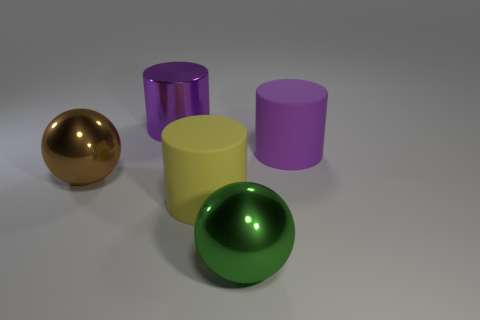Is there any other thing that is the same shape as the purple matte thing?
Your response must be concise. Yes. What color is the other thing that is the same shape as the large brown metallic thing?
Offer a very short reply. Green. What is the color of the other cylinder that is made of the same material as the large yellow cylinder?
Offer a very short reply. Purple. Are there the same number of yellow objects behind the purple metallic cylinder and big green objects?
Make the answer very short. No. There is a metal ball that is in front of the brown metal sphere; does it have the same size as the metallic cylinder?
Ensure brevity in your answer.  Yes. There is another matte object that is the same size as the purple rubber object; what color is it?
Give a very brief answer. Yellow. There is a purple object that is right of the shiny thing that is in front of the brown metal thing; is there a shiny object that is behind it?
Keep it short and to the point. Yes. What material is the cylinder that is to the left of the yellow matte thing?
Offer a terse response. Metal. Do the big purple rubber object and the large purple metal object on the left side of the yellow thing have the same shape?
Your answer should be very brief. Yes. Are there the same number of big metallic spheres behind the large green metallic ball and big purple objects in front of the big purple rubber cylinder?
Ensure brevity in your answer.  No. 